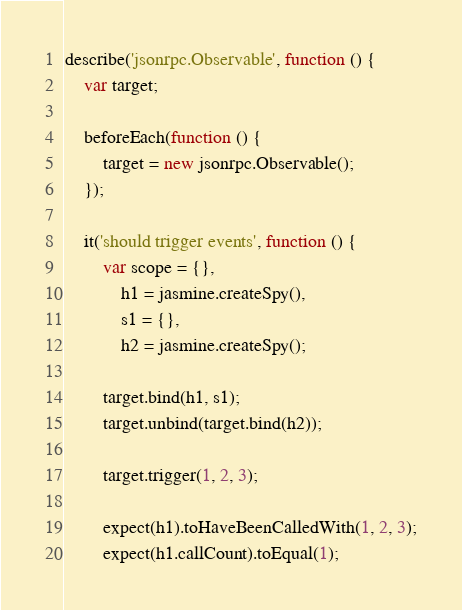Convert code to text. <code><loc_0><loc_0><loc_500><loc_500><_JavaScript_>describe('jsonrpc.Observable', function () {
	var target;

	beforeEach(function () {
		target = new jsonrpc.Observable();
	});

	it('should trigger events', function () {
		var scope = {},
			h1 = jasmine.createSpy(),
			s1 = {},
			h2 = jasmine.createSpy();

		target.bind(h1, s1);
		target.unbind(target.bind(h2));

		target.trigger(1, 2, 3);

		expect(h1).toHaveBeenCalledWith(1, 2, 3);
		expect(h1.callCount).toEqual(1);</code> 